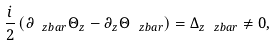Convert formula to latex. <formula><loc_0><loc_0><loc_500><loc_500>\frac { i } { 2 } \, ( \partial _ { \ z b a r } \Theta _ { z } - \partial _ { z } \Theta _ { \ z b a r } ) = \Delta _ { z \ z b a r } \neq 0 ,</formula> 